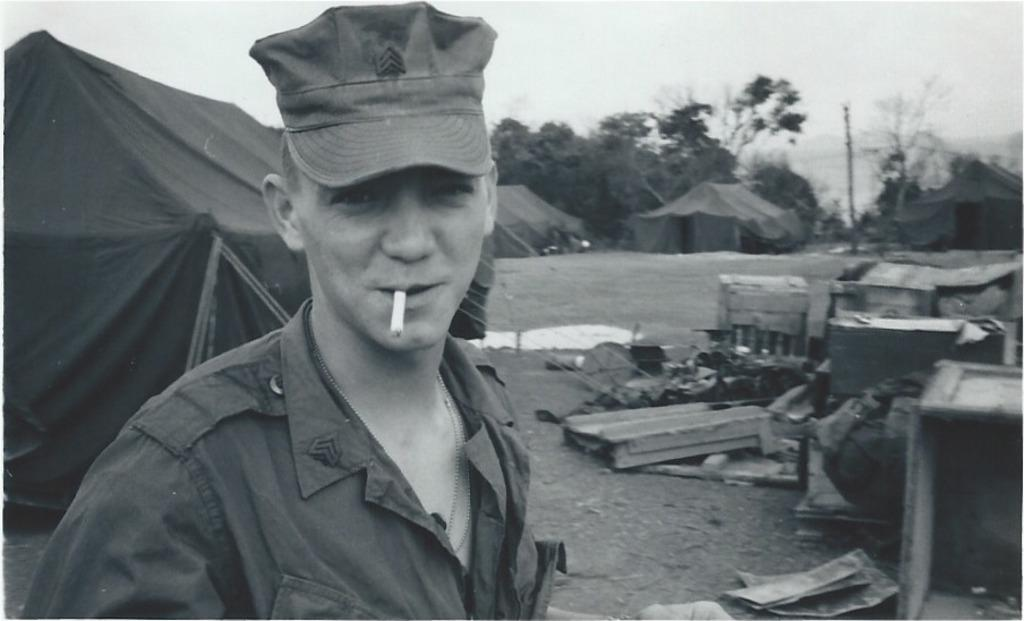What is the color scheme of the image? The image is black and white. What structures can be seen in the image? There are tents in the image. Who is present in the image? There is a man in the image. What objects are on the right side of the image? Wooden boxes are present on the right side of the image. What can be seen in the background of the image? There are trees in the background of the image. What type of rat can be seen in the image? There is no rat present in the image. What is the man's reaction to the surprise in the image? There is no surprise depicted in the image, so the man's reaction cannot be determined. 